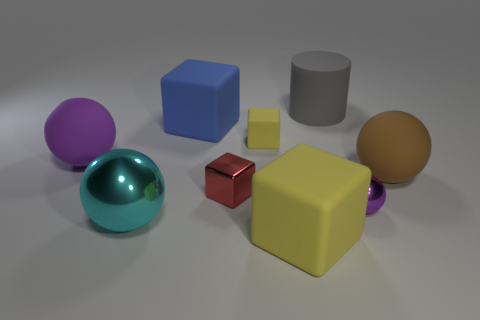There is a large matte sphere to the right of the tiny sphere; is its color the same as the small shiny cube?
Keep it short and to the point. No. Are there any other things of the same color as the big shiny thing?
Offer a terse response. No. Are there more purple shiny spheres behind the brown rubber sphere than cyan metal objects?
Your answer should be very brief. No. Is the size of the purple rubber thing the same as the gray rubber cylinder?
Provide a succinct answer. Yes. There is a large purple object that is the same shape as the big cyan thing; what material is it?
Your answer should be very brief. Rubber. What number of gray things are either big metal spheres or tiny matte things?
Provide a succinct answer. 0. There is a yellow thing that is in front of the tiny purple thing; what is it made of?
Make the answer very short. Rubber. Is the number of purple cylinders greater than the number of matte balls?
Keep it short and to the point. No. There is a yellow matte thing that is in front of the brown thing; is its shape the same as the big brown rubber object?
Provide a succinct answer. No. What number of things are to the left of the large gray rubber cylinder and in front of the big blue rubber thing?
Offer a terse response. 5. 